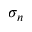Convert formula to latex. <formula><loc_0><loc_0><loc_500><loc_500>\sigma _ { n }</formula> 